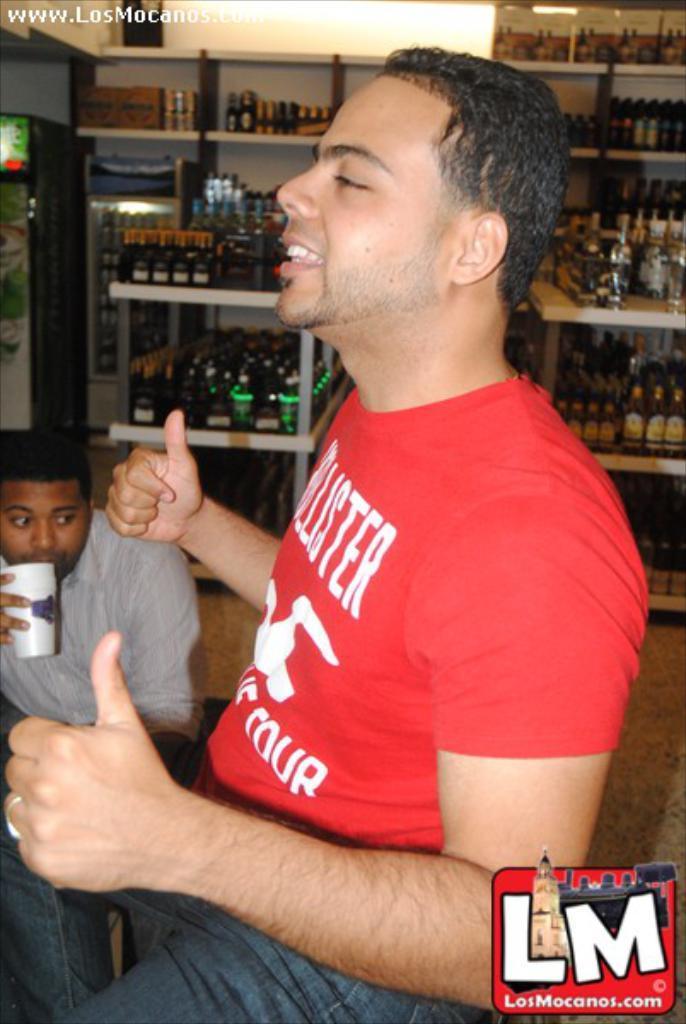How would you summarize this image in a sentence or two? Here I can see a man wearing red color t-shirt, jeans, sitting facing towards the left side. On the left side there is another person holding a glass in the hand. In the background there are many bottles arranged in the racks. In the bottom right there is a logo. 